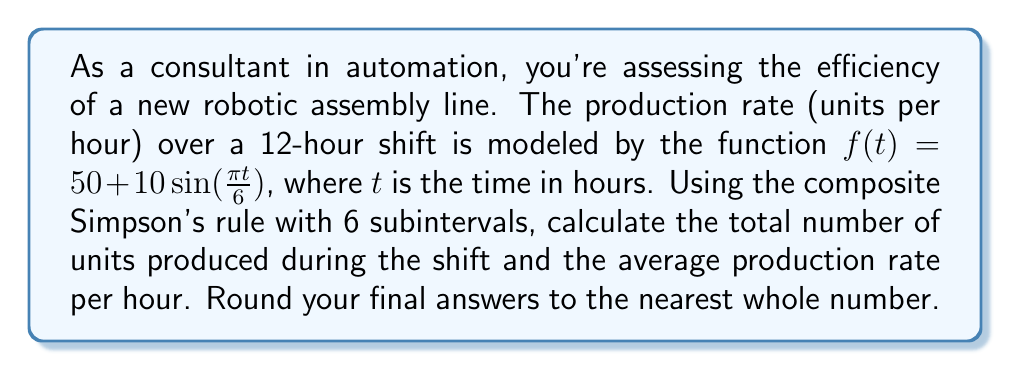Could you help me with this problem? 1) To find the total number of units produced, we need to integrate the production rate function over the 12-hour period:

   $\int_0^{12} f(t) dt = \int_0^{12} (50 + 10\sin(\frac{\pi t}{6})) dt$

2) We'll use the composite Simpson's rule with 6 subintervals. The formula is:

   $\int_a^b f(x) dx \approx \frac{h}{3}[f(x_0) + 4f(x_1) + 2f(x_2) + 4f(x_3) + 2f(x_4) + 4f(x_5) + f(x_6)]$

   where $h = \frac{b-a}{6} = \frac{12-0}{6} = 2$

3) Calculate the function values:
   $f(0) = 50 + 10\sin(0) = 50$
   $f(2) = 50 + 10\sin(\frac{\pi}{3}) \approx 58.66$
   $f(4) = 50 + 10\sin(\frac{2\pi}{3}) \approx 58.66$
   $f(6) = 50 + 10\sin(\pi) = 50$
   $f(8) = 50 + 10\sin(\frac{4\pi}{3}) \approx 41.34$
   $f(10) = 50 + 10\sin(\frac{5\pi}{3}) \approx 41.34$
   $f(12) = 50 + 10\sin(2\pi) = 50$

4) Apply the Simpson's rule:
   $\frac{2}{3}[50 + 4(58.66) + 2(58.66) + 4(50) + 2(41.34) + 4(41.34) + 50] \approx 600$

5) The total number of units produced is approximately 600.

6) To find the average production rate, divide the total by 12 hours:
   $\frac{600}{12} = 50$ units per hour
Answer: 600 units; 50 units/hour 